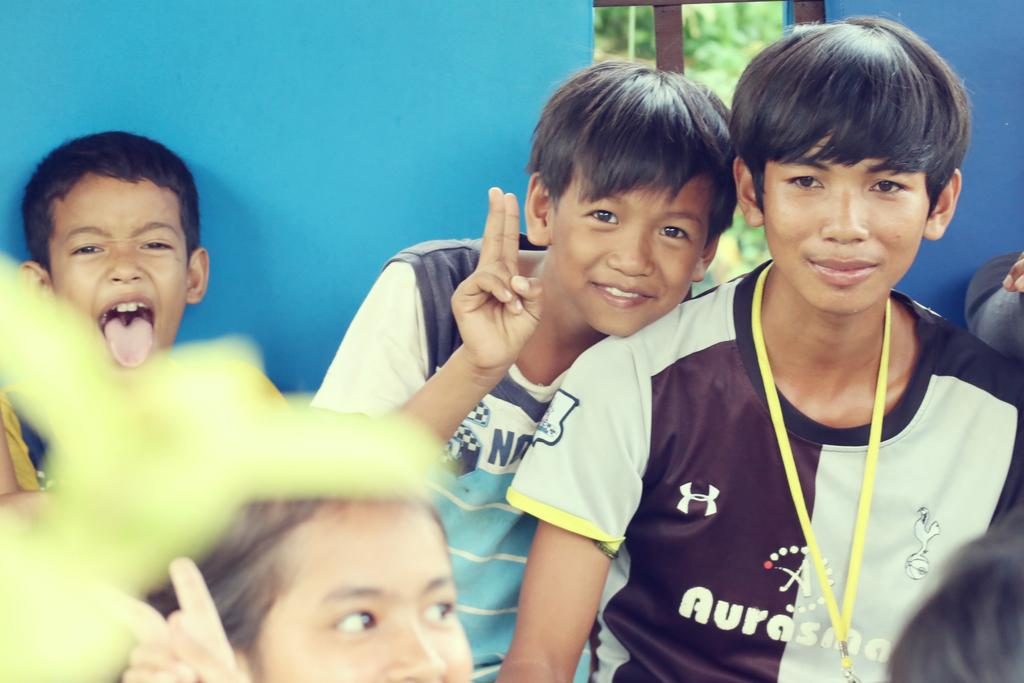Provide a one-sentence caption for the provided image. A boy with an Aurasma jersey on is with friends. 